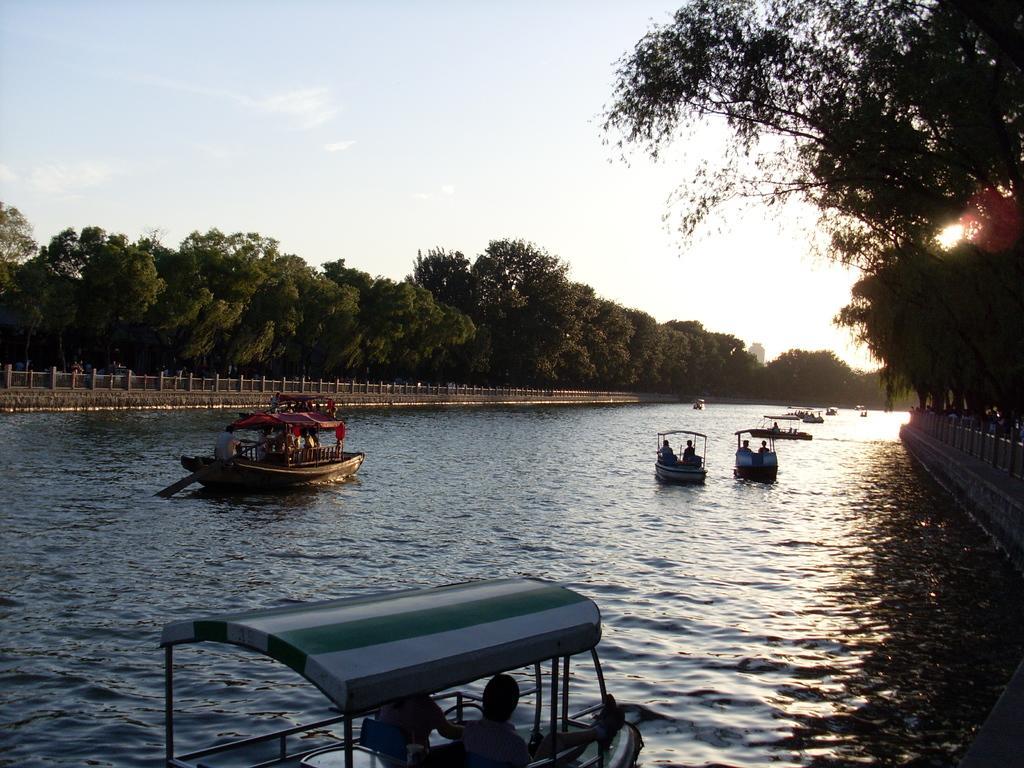Can you describe this image briefly? In this image I can see the water surface. I can see few boats on the water. I can see few trees. At the top I can see clouds in the sky. 